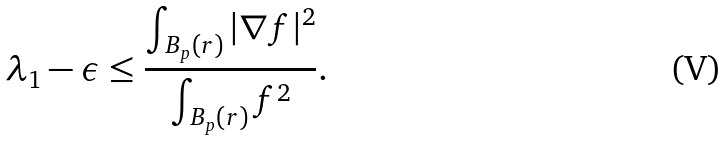<formula> <loc_0><loc_0><loc_500><loc_500>\lambda _ { 1 } - \epsilon \leq \frac { \int _ { B _ { p } ( r ) } | \nabla f | ^ { 2 } } { \int _ { B _ { p } ( r ) } f ^ { 2 } } .</formula> 